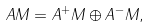Convert formula to latex. <formula><loc_0><loc_0><loc_500><loc_500>A M = A ^ { + } M \oplus A ^ { - } M ,</formula> 